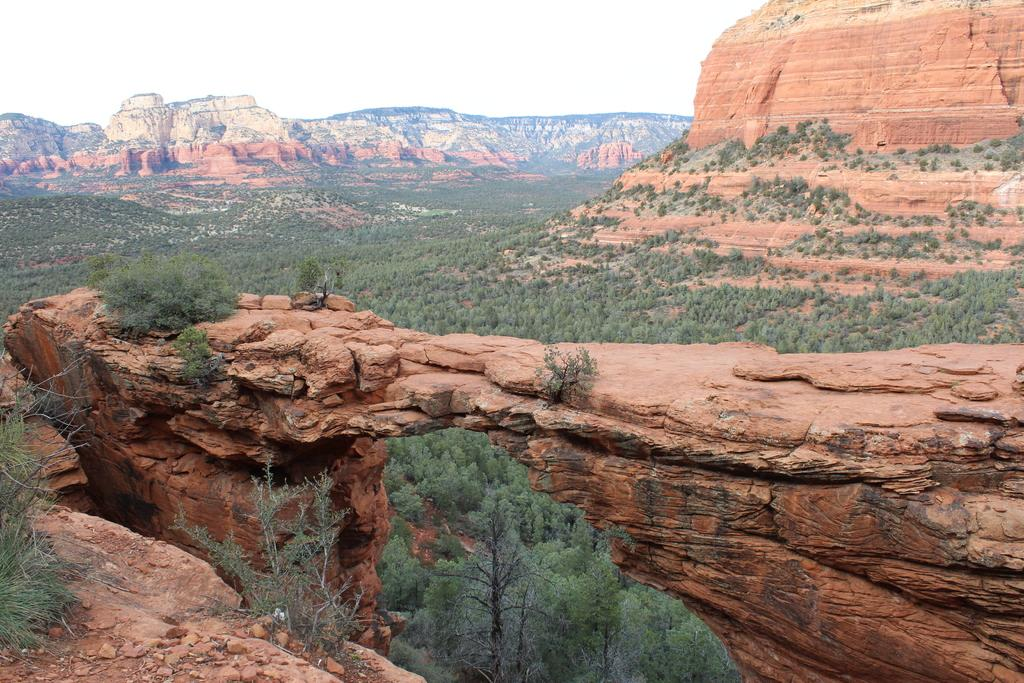What type of geographical feature is present in the image? There are rock hills in the image. What other natural elements can be seen in the image? There are trees in the image. What can be seen in the background of the image? The sky is visible in the background of the image. How many boats are visible in the image? There are no boats present in the image. What type of volcanic activity can be observed in the image? There is no volcanic activity present in the image. 